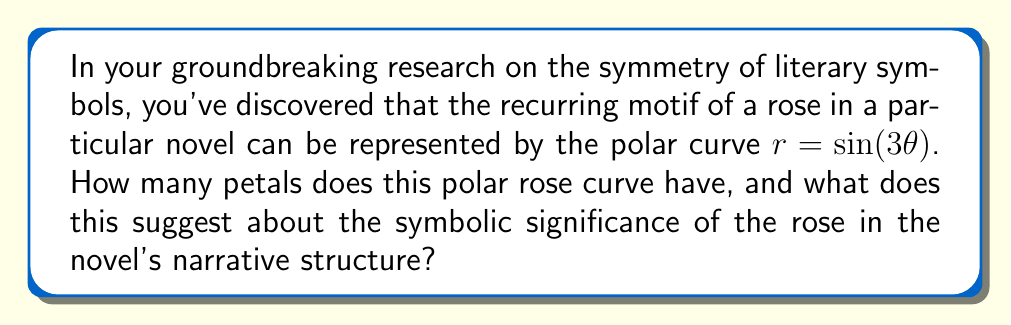Help me with this question. To analyze this problem, we need to understand the properties of polar rose curves:

1) The general equation for a polar rose is $r = a \sin(n\theta)$ or $r = a \cos(n\theta)$, where $a$ is the amplitude and $n$ is the frequency.

2) In this case, we have $r = \sin(3\theta)$, so $a = 1$ and $n = 3$.

3) The number of petals in a polar rose curve depends on $n$:
   - If $n$ is odd, the number of petals is $n$.
   - If $n$ is even, the number of petals is $2n$.

4) In our equation, $n = 3$, which is odd. Therefore, the number of petals is 3.

5) To visualize this, we can plot the curve:

[asy]
import graph;
size(200);
real r(real t) {return sin(3*t);}
draw(polargraph(r,0,2pi),red);
draw(circle(0,1),gray+dashed);
draw((0,-1.2)--(0,1.2),gray+dashed);
draw((-1.2,0)--(1.2,0),gray+dashed);
label("$\theta = 0$", (1.2,0), E);
[/asy]

6) In literary analysis, the number 3 often holds significant symbolic meaning, such as:
   - Representing balance or completeness
   - Alluding to classical literary structures (beginning, middle, end)
   - Symbolizing important triads in literature or mythology

7) The symmetry of the three-petaled rose suggests a balanced, cyclical structure in the novel's narrative, possibly indicating:
   - Three main plot points or character arcs
   - A recurring theme or motif that appears in three variations
   - A triangular relationship between characters or concepts

This mathematical representation provides a unique lens through which to analyze the novel's structure and symbolism, bridging the gap between quantitative and qualitative literary analysis.
Answer: The polar rose curve $r = \sin(3\theta)$ has 3 petals. This suggests that the rose symbol in the novel likely represents a tripartite structure or concept, emphasizing balance, completeness, or a cyclical narrative pattern that repeats three times throughout the work. 